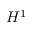Convert formula to latex. <formula><loc_0><loc_0><loc_500><loc_500>H ^ { 1 }</formula> 